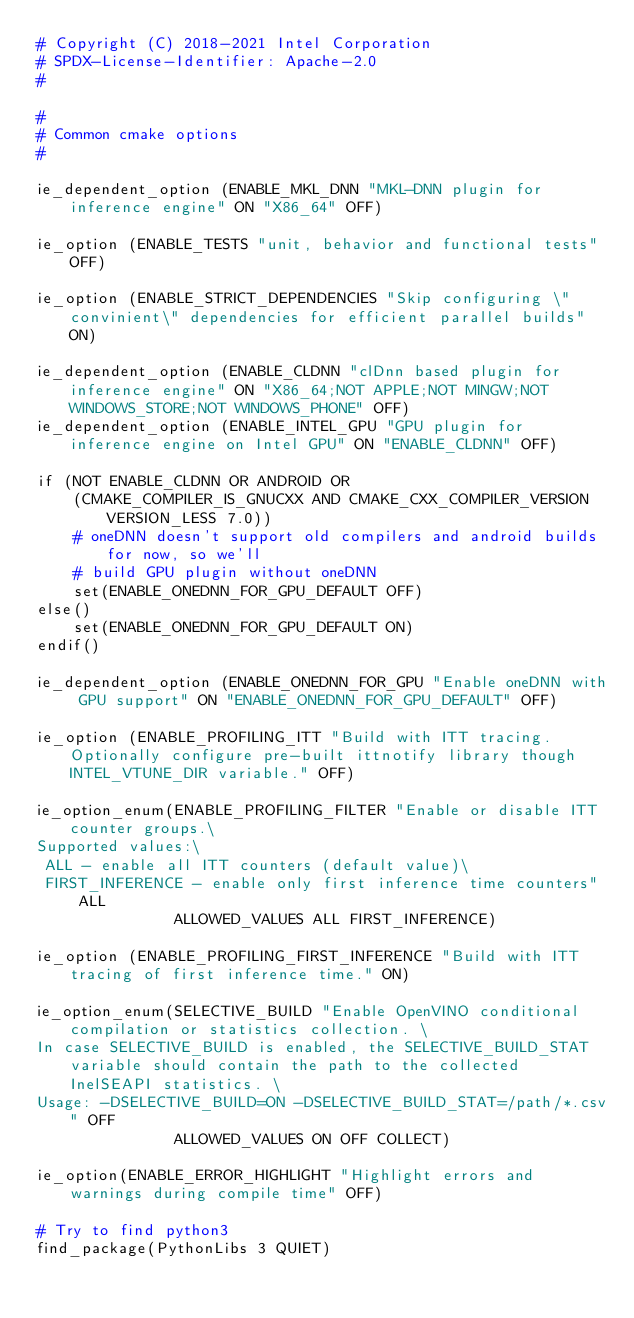Convert code to text. <code><loc_0><loc_0><loc_500><loc_500><_CMake_># Copyright (C) 2018-2021 Intel Corporation
# SPDX-License-Identifier: Apache-2.0
#

#
# Common cmake options
#

ie_dependent_option (ENABLE_MKL_DNN "MKL-DNN plugin for inference engine" ON "X86_64" OFF)

ie_option (ENABLE_TESTS "unit, behavior and functional tests" OFF)

ie_option (ENABLE_STRICT_DEPENDENCIES "Skip configuring \"convinient\" dependencies for efficient parallel builds" ON)

ie_dependent_option (ENABLE_CLDNN "clDnn based plugin for inference engine" ON "X86_64;NOT APPLE;NOT MINGW;NOT WINDOWS_STORE;NOT WINDOWS_PHONE" OFF)
ie_dependent_option (ENABLE_INTEL_GPU "GPU plugin for inference engine on Intel GPU" ON "ENABLE_CLDNN" OFF)

if (NOT ENABLE_CLDNN OR ANDROID OR
    (CMAKE_COMPILER_IS_GNUCXX AND CMAKE_CXX_COMPILER_VERSION VERSION_LESS 7.0))
    # oneDNN doesn't support old compilers and android builds for now, so we'll
    # build GPU plugin without oneDNN
    set(ENABLE_ONEDNN_FOR_GPU_DEFAULT OFF)
else()
    set(ENABLE_ONEDNN_FOR_GPU_DEFAULT ON)
endif()

ie_dependent_option (ENABLE_ONEDNN_FOR_GPU "Enable oneDNN with GPU support" ON "ENABLE_ONEDNN_FOR_GPU_DEFAULT" OFF)

ie_option (ENABLE_PROFILING_ITT "Build with ITT tracing. Optionally configure pre-built ittnotify library though INTEL_VTUNE_DIR variable." OFF)

ie_option_enum(ENABLE_PROFILING_FILTER "Enable or disable ITT counter groups.\
Supported values:\
 ALL - enable all ITT counters (default value)\
 FIRST_INFERENCE - enable only first inference time counters" ALL
               ALLOWED_VALUES ALL FIRST_INFERENCE)

ie_option (ENABLE_PROFILING_FIRST_INFERENCE "Build with ITT tracing of first inference time." ON)

ie_option_enum(SELECTIVE_BUILD "Enable OpenVINO conditional compilation or statistics collection. \
In case SELECTIVE_BUILD is enabled, the SELECTIVE_BUILD_STAT variable should contain the path to the collected InelSEAPI statistics. \
Usage: -DSELECTIVE_BUILD=ON -DSELECTIVE_BUILD_STAT=/path/*.csv" OFF
               ALLOWED_VALUES ON OFF COLLECT)

ie_option(ENABLE_ERROR_HIGHLIGHT "Highlight errors and warnings during compile time" OFF)

# Try to find python3
find_package(PythonLibs 3 QUIET)</code> 